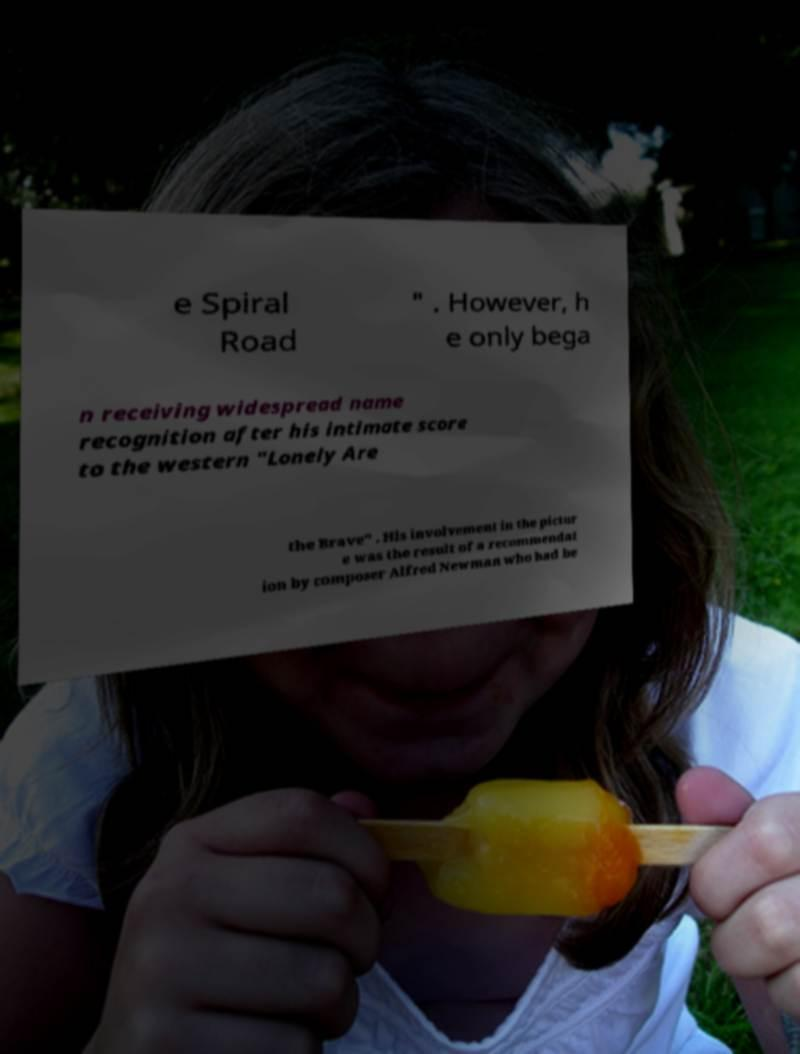There's text embedded in this image that I need extracted. Can you transcribe it verbatim? e Spiral Road " . However, h e only bega n receiving widespread name recognition after his intimate score to the western "Lonely Are the Brave" . His involvement in the pictur e was the result of a recommendat ion by composer Alfred Newman who had be 